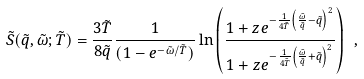Convert formula to latex. <formula><loc_0><loc_0><loc_500><loc_500>\tilde { S } ( \tilde { q } , \tilde { \omega } ; \tilde { T } ) = \frac { 3 \tilde { T } } { 8 \tilde { q } } \frac { 1 } { ( 1 - e ^ { - \tilde { \omega } / \tilde { T } } ) } \ln \left ( \frac { 1 + z e ^ { - \frac { 1 } { 4 \tilde { T } } \left ( \frac { \tilde { \omega } } { \tilde { q } } - \tilde { q } \right ) ^ { 2 } } } { 1 + z e ^ { - \frac { 1 } { 4 \tilde { T } } \left ( \frac { \tilde { \omega } } { \tilde { q } } + \tilde { q } \right ) ^ { 2 } } } \right ) \ ,</formula> 